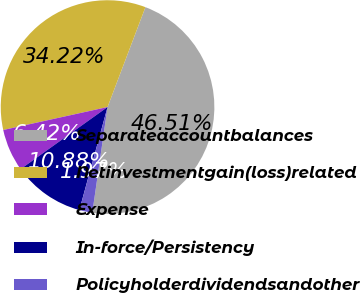Convert chart. <chart><loc_0><loc_0><loc_500><loc_500><pie_chart><fcel>Separateaccountbalances<fcel>Netinvestmentgain(loss)related<fcel>Expense<fcel>In-force/Persistency<fcel>Policyholderdividendsandother<nl><fcel>46.51%<fcel>34.22%<fcel>6.42%<fcel>10.88%<fcel>1.97%<nl></chart> 